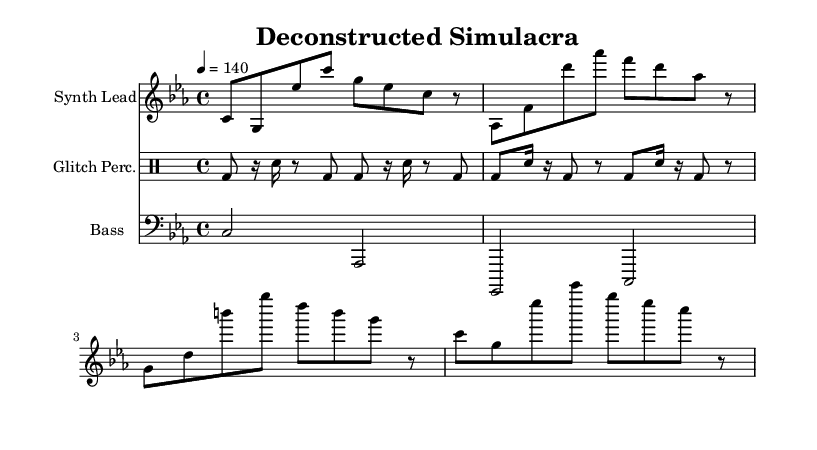What is the key signature of this music? The key signature is C minor, which is indicated by three flat symbols (B flat, E flat, and A flat).
Answer: C minor What is the time signature of this music? The time signature is 4/4, which is shown at the beginning of the notation with the fraction. This indicates there are four beats in each measure and a quarter note gets one beat.
Answer: 4/4 What is the tempo marking for this piece? The tempo marking indicates a speed of 140 beats per minute, shown in the notation with '4 = 140'. This means each quarter note is played at 140 beats in one minute.
Answer: 140 How many measures are in the Synth Lead section? The Synth Lead section contains four measures, as indicated by the grouping of notes separated by vertical lines in the sheet music.
Answer: 4 What instruments are featured in this piece? The featured instruments are a Synth Lead, Glitch Percussion, and Bass, which are labeled at the beginning of each respective staff in the score.
Answer: Synth Lead, Glitch Perc., Bass How does the rhythmic pattern in the Glitch Percussion section compare to the Synth Lead? The Glitch Percussion has more rhythmic variation and shorter notes including rests, while the Synth Lead primarily features longer notes in a legato style, indicating a contrast in texture and complexity.
Answer: Rhythmic variation What type of electronic music is represented here? This piece represents Glitch-hop and IDM, characterized by its intricate rhythmic structures and use of glitches in sound creation, as inferred from its style and notation.
Answer: Glitch-hop and IDM 